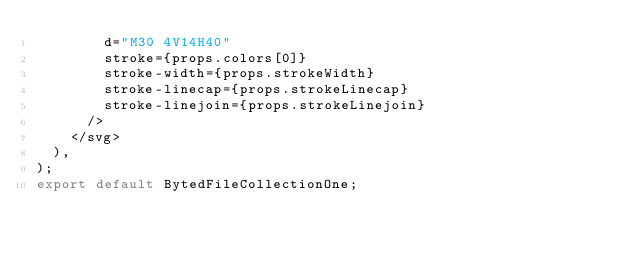<code> <loc_0><loc_0><loc_500><loc_500><_TypeScript_>        d="M30 4V14H40"
        stroke={props.colors[0]}
        stroke-width={props.strokeWidth}
        stroke-linecap={props.strokeLinecap}
        stroke-linejoin={props.strokeLinejoin}
      />
    </svg>
  ),
);
export default BytedFileCollectionOne;
</code> 